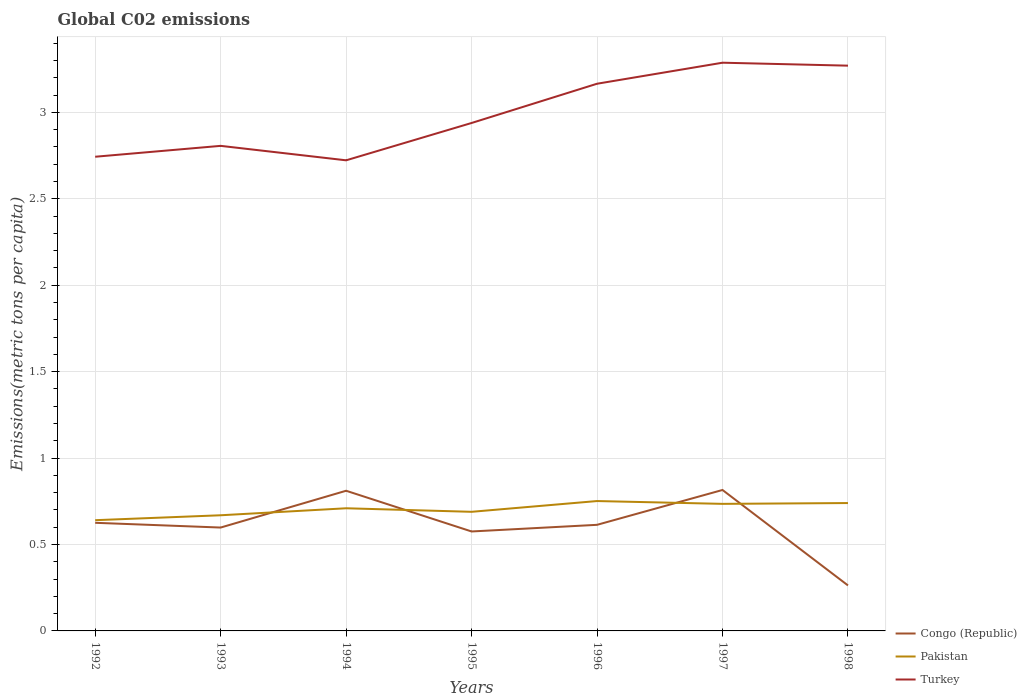Across all years, what is the maximum amount of CO2 emitted in in Pakistan?
Provide a short and direct response. 0.64. In which year was the amount of CO2 emitted in in Pakistan maximum?
Make the answer very short. 1992. What is the total amount of CO2 emitted in in Congo (Republic) in the graph?
Provide a succinct answer. 0.33. What is the difference between the highest and the second highest amount of CO2 emitted in in Turkey?
Keep it short and to the point. 0.56. What is the difference between the highest and the lowest amount of CO2 emitted in in Turkey?
Your response must be concise. 3. How many years are there in the graph?
Provide a succinct answer. 7. Are the values on the major ticks of Y-axis written in scientific E-notation?
Your answer should be very brief. No. How many legend labels are there?
Your answer should be compact. 3. What is the title of the graph?
Keep it short and to the point. Global C02 emissions. What is the label or title of the X-axis?
Ensure brevity in your answer.  Years. What is the label or title of the Y-axis?
Keep it short and to the point. Emissions(metric tons per capita). What is the Emissions(metric tons per capita) in Congo (Republic) in 1992?
Give a very brief answer. 0.63. What is the Emissions(metric tons per capita) in Pakistan in 1992?
Give a very brief answer. 0.64. What is the Emissions(metric tons per capita) of Turkey in 1992?
Provide a short and direct response. 2.74. What is the Emissions(metric tons per capita) in Congo (Republic) in 1993?
Offer a terse response. 0.6. What is the Emissions(metric tons per capita) of Pakistan in 1993?
Provide a short and direct response. 0.67. What is the Emissions(metric tons per capita) in Turkey in 1993?
Provide a short and direct response. 2.81. What is the Emissions(metric tons per capita) of Congo (Republic) in 1994?
Keep it short and to the point. 0.81. What is the Emissions(metric tons per capita) of Pakistan in 1994?
Keep it short and to the point. 0.71. What is the Emissions(metric tons per capita) of Turkey in 1994?
Give a very brief answer. 2.72. What is the Emissions(metric tons per capita) in Congo (Republic) in 1995?
Your response must be concise. 0.58. What is the Emissions(metric tons per capita) of Pakistan in 1995?
Give a very brief answer. 0.69. What is the Emissions(metric tons per capita) of Turkey in 1995?
Provide a short and direct response. 2.94. What is the Emissions(metric tons per capita) in Congo (Republic) in 1996?
Your answer should be very brief. 0.61. What is the Emissions(metric tons per capita) in Pakistan in 1996?
Make the answer very short. 0.75. What is the Emissions(metric tons per capita) in Turkey in 1996?
Ensure brevity in your answer.  3.17. What is the Emissions(metric tons per capita) in Congo (Republic) in 1997?
Keep it short and to the point. 0.82. What is the Emissions(metric tons per capita) of Pakistan in 1997?
Your response must be concise. 0.74. What is the Emissions(metric tons per capita) in Turkey in 1997?
Your answer should be very brief. 3.29. What is the Emissions(metric tons per capita) in Congo (Republic) in 1998?
Ensure brevity in your answer.  0.26. What is the Emissions(metric tons per capita) in Pakistan in 1998?
Keep it short and to the point. 0.74. What is the Emissions(metric tons per capita) in Turkey in 1998?
Provide a succinct answer. 3.27. Across all years, what is the maximum Emissions(metric tons per capita) in Congo (Republic)?
Make the answer very short. 0.82. Across all years, what is the maximum Emissions(metric tons per capita) of Pakistan?
Your response must be concise. 0.75. Across all years, what is the maximum Emissions(metric tons per capita) of Turkey?
Offer a very short reply. 3.29. Across all years, what is the minimum Emissions(metric tons per capita) of Congo (Republic)?
Your response must be concise. 0.26. Across all years, what is the minimum Emissions(metric tons per capita) in Pakistan?
Make the answer very short. 0.64. Across all years, what is the minimum Emissions(metric tons per capita) of Turkey?
Keep it short and to the point. 2.72. What is the total Emissions(metric tons per capita) in Congo (Republic) in the graph?
Your answer should be compact. 4.3. What is the total Emissions(metric tons per capita) of Pakistan in the graph?
Offer a terse response. 4.93. What is the total Emissions(metric tons per capita) of Turkey in the graph?
Make the answer very short. 20.93. What is the difference between the Emissions(metric tons per capita) of Congo (Republic) in 1992 and that in 1993?
Ensure brevity in your answer.  0.03. What is the difference between the Emissions(metric tons per capita) of Pakistan in 1992 and that in 1993?
Ensure brevity in your answer.  -0.03. What is the difference between the Emissions(metric tons per capita) of Turkey in 1992 and that in 1993?
Provide a succinct answer. -0.06. What is the difference between the Emissions(metric tons per capita) of Congo (Republic) in 1992 and that in 1994?
Give a very brief answer. -0.19. What is the difference between the Emissions(metric tons per capita) of Pakistan in 1992 and that in 1994?
Your answer should be compact. -0.07. What is the difference between the Emissions(metric tons per capita) of Turkey in 1992 and that in 1994?
Your response must be concise. 0.02. What is the difference between the Emissions(metric tons per capita) in Congo (Republic) in 1992 and that in 1995?
Your response must be concise. 0.05. What is the difference between the Emissions(metric tons per capita) in Pakistan in 1992 and that in 1995?
Your response must be concise. -0.05. What is the difference between the Emissions(metric tons per capita) in Turkey in 1992 and that in 1995?
Your response must be concise. -0.2. What is the difference between the Emissions(metric tons per capita) of Congo (Republic) in 1992 and that in 1996?
Give a very brief answer. 0.01. What is the difference between the Emissions(metric tons per capita) in Pakistan in 1992 and that in 1996?
Your answer should be very brief. -0.11. What is the difference between the Emissions(metric tons per capita) in Turkey in 1992 and that in 1996?
Ensure brevity in your answer.  -0.42. What is the difference between the Emissions(metric tons per capita) in Congo (Republic) in 1992 and that in 1997?
Offer a terse response. -0.19. What is the difference between the Emissions(metric tons per capita) of Pakistan in 1992 and that in 1997?
Your answer should be compact. -0.09. What is the difference between the Emissions(metric tons per capita) of Turkey in 1992 and that in 1997?
Your response must be concise. -0.54. What is the difference between the Emissions(metric tons per capita) in Congo (Republic) in 1992 and that in 1998?
Offer a terse response. 0.36. What is the difference between the Emissions(metric tons per capita) in Pakistan in 1992 and that in 1998?
Provide a succinct answer. -0.1. What is the difference between the Emissions(metric tons per capita) of Turkey in 1992 and that in 1998?
Offer a terse response. -0.53. What is the difference between the Emissions(metric tons per capita) of Congo (Republic) in 1993 and that in 1994?
Give a very brief answer. -0.21. What is the difference between the Emissions(metric tons per capita) in Pakistan in 1993 and that in 1994?
Your answer should be very brief. -0.04. What is the difference between the Emissions(metric tons per capita) in Turkey in 1993 and that in 1994?
Keep it short and to the point. 0.08. What is the difference between the Emissions(metric tons per capita) in Congo (Republic) in 1993 and that in 1995?
Your response must be concise. 0.02. What is the difference between the Emissions(metric tons per capita) in Pakistan in 1993 and that in 1995?
Your answer should be very brief. -0.02. What is the difference between the Emissions(metric tons per capita) in Turkey in 1993 and that in 1995?
Offer a terse response. -0.13. What is the difference between the Emissions(metric tons per capita) in Congo (Republic) in 1993 and that in 1996?
Give a very brief answer. -0.02. What is the difference between the Emissions(metric tons per capita) of Pakistan in 1993 and that in 1996?
Give a very brief answer. -0.08. What is the difference between the Emissions(metric tons per capita) of Turkey in 1993 and that in 1996?
Keep it short and to the point. -0.36. What is the difference between the Emissions(metric tons per capita) in Congo (Republic) in 1993 and that in 1997?
Offer a terse response. -0.22. What is the difference between the Emissions(metric tons per capita) of Pakistan in 1993 and that in 1997?
Offer a terse response. -0.07. What is the difference between the Emissions(metric tons per capita) in Turkey in 1993 and that in 1997?
Give a very brief answer. -0.48. What is the difference between the Emissions(metric tons per capita) in Congo (Republic) in 1993 and that in 1998?
Keep it short and to the point. 0.33. What is the difference between the Emissions(metric tons per capita) in Pakistan in 1993 and that in 1998?
Your response must be concise. -0.07. What is the difference between the Emissions(metric tons per capita) in Turkey in 1993 and that in 1998?
Keep it short and to the point. -0.46. What is the difference between the Emissions(metric tons per capita) in Congo (Republic) in 1994 and that in 1995?
Offer a terse response. 0.24. What is the difference between the Emissions(metric tons per capita) of Pakistan in 1994 and that in 1995?
Give a very brief answer. 0.02. What is the difference between the Emissions(metric tons per capita) in Turkey in 1994 and that in 1995?
Give a very brief answer. -0.22. What is the difference between the Emissions(metric tons per capita) in Congo (Republic) in 1994 and that in 1996?
Your answer should be compact. 0.2. What is the difference between the Emissions(metric tons per capita) of Pakistan in 1994 and that in 1996?
Your answer should be very brief. -0.04. What is the difference between the Emissions(metric tons per capita) in Turkey in 1994 and that in 1996?
Your response must be concise. -0.44. What is the difference between the Emissions(metric tons per capita) of Congo (Republic) in 1994 and that in 1997?
Provide a succinct answer. -0. What is the difference between the Emissions(metric tons per capita) in Pakistan in 1994 and that in 1997?
Ensure brevity in your answer.  -0.03. What is the difference between the Emissions(metric tons per capita) in Turkey in 1994 and that in 1997?
Provide a short and direct response. -0.56. What is the difference between the Emissions(metric tons per capita) of Congo (Republic) in 1994 and that in 1998?
Your response must be concise. 0.55. What is the difference between the Emissions(metric tons per capita) of Pakistan in 1994 and that in 1998?
Provide a succinct answer. -0.03. What is the difference between the Emissions(metric tons per capita) of Turkey in 1994 and that in 1998?
Your answer should be very brief. -0.55. What is the difference between the Emissions(metric tons per capita) of Congo (Republic) in 1995 and that in 1996?
Ensure brevity in your answer.  -0.04. What is the difference between the Emissions(metric tons per capita) of Pakistan in 1995 and that in 1996?
Ensure brevity in your answer.  -0.06. What is the difference between the Emissions(metric tons per capita) in Turkey in 1995 and that in 1996?
Make the answer very short. -0.23. What is the difference between the Emissions(metric tons per capita) in Congo (Republic) in 1995 and that in 1997?
Your answer should be very brief. -0.24. What is the difference between the Emissions(metric tons per capita) in Pakistan in 1995 and that in 1997?
Offer a very short reply. -0.05. What is the difference between the Emissions(metric tons per capita) in Turkey in 1995 and that in 1997?
Your answer should be very brief. -0.35. What is the difference between the Emissions(metric tons per capita) of Congo (Republic) in 1995 and that in 1998?
Offer a very short reply. 0.31. What is the difference between the Emissions(metric tons per capita) of Pakistan in 1995 and that in 1998?
Make the answer very short. -0.05. What is the difference between the Emissions(metric tons per capita) of Turkey in 1995 and that in 1998?
Your answer should be very brief. -0.33. What is the difference between the Emissions(metric tons per capita) in Congo (Republic) in 1996 and that in 1997?
Make the answer very short. -0.2. What is the difference between the Emissions(metric tons per capita) in Pakistan in 1996 and that in 1997?
Your answer should be very brief. 0.02. What is the difference between the Emissions(metric tons per capita) in Turkey in 1996 and that in 1997?
Ensure brevity in your answer.  -0.12. What is the difference between the Emissions(metric tons per capita) of Congo (Republic) in 1996 and that in 1998?
Offer a terse response. 0.35. What is the difference between the Emissions(metric tons per capita) of Pakistan in 1996 and that in 1998?
Keep it short and to the point. 0.01. What is the difference between the Emissions(metric tons per capita) in Turkey in 1996 and that in 1998?
Provide a succinct answer. -0.1. What is the difference between the Emissions(metric tons per capita) in Congo (Republic) in 1997 and that in 1998?
Ensure brevity in your answer.  0.55. What is the difference between the Emissions(metric tons per capita) of Pakistan in 1997 and that in 1998?
Offer a very short reply. -0. What is the difference between the Emissions(metric tons per capita) in Turkey in 1997 and that in 1998?
Your answer should be very brief. 0.02. What is the difference between the Emissions(metric tons per capita) in Congo (Republic) in 1992 and the Emissions(metric tons per capita) in Pakistan in 1993?
Provide a short and direct response. -0.04. What is the difference between the Emissions(metric tons per capita) in Congo (Republic) in 1992 and the Emissions(metric tons per capita) in Turkey in 1993?
Your answer should be compact. -2.18. What is the difference between the Emissions(metric tons per capita) of Pakistan in 1992 and the Emissions(metric tons per capita) of Turkey in 1993?
Your answer should be very brief. -2.17. What is the difference between the Emissions(metric tons per capita) in Congo (Republic) in 1992 and the Emissions(metric tons per capita) in Pakistan in 1994?
Ensure brevity in your answer.  -0.08. What is the difference between the Emissions(metric tons per capita) of Congo (Republic) in 1992 and the Emissions(metric tons per capita) of Turkey in 1994?
Provide a succinct answer. -2.1. What is the difference between the Emissions(metric tons per capita) of Pakistan in 1992 and the Emissions(metric tons per capita) of Turkey in 1994?
Keep it short and to the point. -2.08. What is the difference between the Emissions(metric tons per capita) of Congo (Republic) in 1992 and the Emissions(metric tons per capita) of Pakistan in 1995?
Keep it short and to the point. -0.06. What is the difference between the Emissions(metric tons per capita) in Congo (Republic) in 1992 and the Emissions(metric tons per capita) in Turkey in 1995?
Your response must be concise. -2.31. What is the difference between the Emissions(metric tons per capita) in Pakistan in 1992 and the Emissions(metric tons per capita) in Turkey in 1995?
Your answer should be very brief. -2.3. What is the difference between the Emissions(metric tons per capita) of Congo (Republic) in 1992 and the Emissions(metric tons per capita) of Pakistan in 1996?
Give a very brief answer. -0.13. What is the difference between the Emissions(metric tons per capita) of Congo (Republic) in 1992 and the Emissions(metric tons per capita) of Turkey in 1996?
Make the answer very short. -2.54. What is the difference between the Emissions(metric tons per capita) in Pakistan in 1992 and the Emissions(metric tons per capita) in Turkey in 1996?
Keep it short and to the point. -2.52. What is the difference between the Emissions(metric tons per capita) in Congo (Republic) in 1992 and the Emissions(metric tons per capita) in Pakistan in 1997?
Provide a short and direct response. -0.11. What is the difference between the Emissions(metric tons per capita) in Congo (Republic) in 1992 and the Emissions(metric tons per capita) in Turkey in 1997?
Provide a short and direct response. -2.66. What is the difference between the Emissions(metric tons per capita) in Pakistan in 1992 and the Emissions(metric tons per capita) in Turkey in 1997?
Provide a short and direct response. -2.65. What is the difference between the Emissions(metric tons per capita) in Congo (Republic) in 1992 and the Emissions(metric tons per capita) in Pakistan in 1998?
Your answer should be very brief. -0.11. What is the difference between the Emissions(metric tons per capita) in Congo (Republic) in 1992 and the Emissions(metric tons per capita) in Turkey in 1998?
Keep it short and to the point. -2.64. What is the difference between the Emissions(metric tons per capita) of Pakistan in 1992 and the Emissions(metric tons per capita) of Turkey in 1998?
Your answer should be compact. -2.63. What is the difference between the Emissions(metric tons per capita) in Congo (Republic) in 1993 and the Emissions(metric tons per capita) in Pakistan in 1994?
Provide a succinct answer. -0.11. What is the difference between the Emissions(metric tons per capita) of Congo (Republic) in 1993 and the Emissions(metric tons per capita) of Turkey in 1994?
Keep it short and to the point. -2.12. What is the difference between the Emissions(metric tons per capita) of Pakistan in 1993 and the Emissions(metric tons per capita) of Turkey in 1994?
Your answer should be very brief. -2.05. What is the difference between the Emissions(metric tons per capita) in Congo (Republic) in 1993 and the Emissions(metric tons per capita) in Pakistan in 1995?
Your response must be concise. -0.09. What is the difference between the Emissions(metric tons per capita) of Congo (Republic) in 1993 and the Emissions(metric tons per capita) of Turkey in 1995?
Ensure brevity in your answer.  -2.34. What is the difference between the Emissions(metric tons per capita) in Pakistan in 1993 and the Emissions(metric tons per capita) in Turkey in 1995?
Your response must be concise. -2.27. What is the difference between the Emissions(metric tons per capita) of Congo (Republic) in 1993 and the Emissions(metric tons per capita) of Pakistan in 1996?
Offer a terse response. -0.15. What is the difference between the Emissions(metric tons per capita) in Congo (Republic) in 1993 and the Emissions(metric tons per capita) in Turkey in 1996?
Your answer should be very brief. -2.57. What is the difference between the Emissions(metric tons per capita) of Pakistan in 1993 and the Emissions(metric tons per capita) of Turkey in 1996?
Give a very brief answer. -2.5. What is the difference between the Emissions(metric tons per capita) of Congo (Republic) in 1993 and the Emissions(metric tons per capita) of Pakistan in 1997?
Provide a short and direct response. -0.14. What is the difference between the Emissions(metric tons per capita) of Congo (Republic) in 1993 and the Emissions(metric tons per capita) of Turkey in 1997?
Your answer should be compact. -2.69. What is the difference between the Emissions(metric tons per capita) of Pakistan in 1993 and the Emissions(metric tons per capita) of Turkey in 1997?
Your response must be concise. -2.62. What is the difference between the Emissions(metric tons per capita) in Congo (Republic) in 1993 and the Emissions(metric tons per capita) in Pakistan in 1998?
Offer a very short reply. -0.14. What is the difference between the Emissions(metric tons per capita) in Congo (Republic) in 1993 and the Emissions(metric tons per capita) in Turkey in 1998?
Give a very brief answer. -2.67. What is the difference between the Emissions(metric tons per capita) in Pakistan in 1993 and the Emissions(metric tons per capita) in Turkey in 1998?
Make the answer very short. -2.6. What is the difference between the Emissions(metric tons per capita) in Congo (Republic) in 1994 and the Emissions(metric tons per capita) in Pakistan in 1995?
Keep it short and to the point. 0.12. What is the difference between the Emissions(metric tons per capita) of Congo (Republic) in 1994 and the Emissions(metric tons per capita) of Turkey in 1995?
Ensure brevity in your answer.  -2.13. What is the difference between the Emissions(metric tons per capita) in Pakistan in 1994 and the Emissions(metric tons per capita) in Turkey in 1995?
Offer a terse response. -2.23. What is the difference between the Emissions(metric tons per capita) in Congo (Republic) in 1994 and the Emissions(metric tons per capita) in Pakistan in 1996?
Offer a very short reply. 0.06. What is the difference between the Emissions(metric tons per capita) of Congo (Republic) in 1994 and the Emissions(metric tons per capita) of Turkey in 1996?
Ensure brevity in your answer.  -2.35. What is the difference between the Emissions(metric tons per capita) in Pakistan in 1994 and the Emissions(metric tons per capita) in Turkey in 1996?
Give a very brief answer. -2.46. What is the difference between the Emissions(metric tons per capita) of Congo (Republic) in 1994 and the Emissions(metric tons per capita) of Pakistan in 1997?
Provide a succinct answer. 0.08. What is the difference between the Emissions(metric tons per capita) of Congo (Republic) in 1994 and the Emissions(metric tons per capita) of Turkey in 1997?
Offer a terse response. -2.48. What is the difference between the Emissions(metric tons per capita) of Pakistan in 1994 and the Emissions(metric tons per capita) of Turkey in 1997?
Your answer should be very brief. -2.58. What is the difference between the Emissions(metric tons per capita) of Congo (Republic) in 1994 and the Emissions(metric tons per capita) of Pakistan in 1998?
Give a very brief answer. 0.07. What is the difference between the Emissions(metric tons per capita) of Congo (Republic) in 1994 and the Emissions(metric tons per capita) of Turkey in 1998?
Keep it short and to the point. -2.46. What is the difference between the Emissions(metric tons per capita) of Pakistan in 1994 and the Emissions(metric tons per capita) of Turkey in 1998?
Provide a succinct answer. -2.56. What is the difference between the Emissions(metric tons per capita) of Congo (Republic) in 1995 and the Emissions(metric tons per capita) of Pakistan in 1996?
Provide a succinct answer. -0.18. What is the difference between the Emissions(metric tons per capita) of Congo (Republic) in 1995 and the Emissions(metric tons per capita) of Turkey in 1996?
Offer a terse response. -2.59. What is the difference between the Emissions(metric tons per capita) in Pakistan in 1995 and the Emissions(metric tons per capita) in Turkey in 1996?
Make the answer very short. -2.48. What is the difference between the Emissions(metric tons per capita) in Congo (Republic) in 1995 and the Emissions(metric tons per capita) in Pakistan in 1997?
Give a very brief answer. -0.16. What is the difference between the Emissions(metric tons per capita) in Congo (Republic) in 1995 and the Emissions(metric tons per capita) in Turkey in 1997?
Your answer should be compact. -2.71. What is the difference between the Emissions(metric tons per capita) of Pakistan in 1995 and the Emissions(metric tons per capita) of Turkey in 1997?
Give a very brief answer. -2.6. What is the difference between the Emissions(metric tons per capita) in Congo (Republic) in 1995 and the Emissions(metric tons per capita) in Pakistan in 1998?
Provide a succinct answer. -0.16. What is the difference between the Emissions(metric tons per capita) of Congo (Republic) in 1995 and the Emissions(metric tons per capita) of Turkey in 1998?
Provide a short and direct response. -2.69. What is the difference between the Emissions(metric tons per capita) of Pakistan in 1995 and the Emissions(metric tons per capita) of Turkey in 1998?
Give a very brief answer. -2.58. What is the difference between the Emissions(metric tons per capita) of Congo (Republic) in 1996 and the Emissions(metric tons per capita) of Pakistan in 1997?
Give a very brief answer. -0.12. What is the difference between the Emissions(metric tons per capita) in Congo (Republic) in 1996 and the Emissions(metric tons per capita) in Turkey in 1997?
Give a very brief answer. -2.67. What is the difference between the Emissions(metric tons per capita) in Pakistan in 1996 and the Emissions(metric tons per capita) in Turkey in 1997?
Your answer should be compact. -2.54. What is the difference between the Emissions(metric tons per capita) in Congo (Republic) in 1996 and the Emissions(metric tons per capita) in Pakistan in 1998?
Offer a terse response. -0.13. What is the difference between the Emissions(metric tons per capita) of Congo (Republic) in 1996 and the Emissions(metric tons per capita) of Turkey in 1998?
Your answer should be very brief. -2.66. What is the difference between the Emissions(metric tons per capita) in Pakistan in 1996 and the Emissions(metric tons per capita) in Turkey in 1998?
Your answer should be very brief. -2.52. What is the difference between the Emissions(metric tons per capita) of Congo (Republic) in 1997 and the Emissions(metric tons per capita) of Pakistan in 1998?
Make the answer very short. 0.08. What is the difference between the Emissions(metric tons per capita) of Congo (Republic) in 1997 and the Emissions(metric tons per capita) of Turkey in 1998?
Provide a short and direct response. -2.45. What is the difference between the Emissions(metric tons per capita) in Pakistan in 1997 and the Emissions(metric tons per capita) in Turkey in 1998?
Offer a terse response. -2.54. What is the average Emissions(metric tons per capita) of Congo (Republic) per year?
Make the answer very short. 0.61. What is the average Emissions(metric tons per capita) of Pakistan per year?
Offer a very short reply. 0.7. What is the average Emissions(metric tons per capita) in Turkey per year?
Keep it short and to the point. 2.99. In the year 1992, what is the difference between the Emissions(metric tons per capita) in Congo (Republic) and Emissions(metric tons per capita) in Pakistan?
Your answer should be compact. -0.02. In the year 1992, what is the difference between the Emissions(metric tons per capita) of Congo (Republic) and Emissions(metric tons per capita) of Turkey?
Give a very brief answer. -2.12. In the year 1992, what is the difference between the Emissions(metric tons per capita) of Pakistan and Emissions(metric tons per capita) of Turkey?
Provide a succinct answer. -2.1. In the year 1993, what is the difference between the Emissions(metric tons per capita) of Congo (Republic) and Emissions(metric tons per capita) of Pakistan?
Offer a terse response. -0.07. In the year 1993, what is the difference between the Emissions(metric tons per capita) in Congo (Republic) and Emissions(metric tons per capita) in Turkey?
Give a very brief answer. -2.21. In the year 1993, what is the difference between the Emissions(metric tons per capita) of Pakistan and Emissions(metric tons per capita) of Turkey?
Keep it short and to the point. -2.14. In the year 1994, what is the difference between the Emissions(metric tons per capita) in Congo (Republic) and Emissions(metric tons per capita) in Pakistan?
Provide a succinct answer. 0.1. In the year 1994, what is the difference between the Emissions(metric tons per capita) of Congo (Republic) and Emissions(metric tons per capita) of Turkey?
Your answer should be very brief. -1.91. In the year 1994, what is the difference between the Emissions(metric tons per capita) in Pakistan and Emissions(metric tons per capita) in Turkey?
Give a very brief answer. -2.01. In the year 1995, what is the difference between the Emissions(metric tons per capita) in Congo (Republic) and Emissions(metric tons per capita) in Pakistan?
Ensure brevity in your answer.  -0.11. In the year 1995, what is the difference between the Emissions(metric tons per capita) of Congo (Republic) and Emissions(metric tons per capita) of Turkey?
Offer a very short reply. -2.36. In the year 1995, what is the difference between the Emissions(metric tons per capita) of Pakistan and Emissions(metric tons per capita) of Turkey?
Your answer should be compact. -2.25. In the year 1996, what is the difference between the Emissions(metric tons per capita) of Congo (Republic) and Emissions(metric tons per capita) of Pakistan?
Provide a short and direct response. -0.14. In the year 1996, what is the difference between the Emissions(metric tons per capita) of Congo (Republic) and Emissions(metric tons per capita) of Turkey?
Provide a short and direct response. -2.55. In the year 1996, what is the difference between the Emissions(metric tons per capita) in Pakistan and Emissions(metric tons per capita) in Turkey?
Your response must be concise. -2.41. In the year 1997, what is the difference between the Emissions(metric tons per capita) of Congo (Republic) and Emissions(metric tons per capita) of Pakistan?
Make the answer very short. 0.08. In the year 1997, what is the difference between the Emissions(metric tons per capita) of Congo (Republic) and Emissions(metric tons per capita) of Turkey?
Give a very brief answer. -2.47. In the year 1997, what is the difference between the Emissions(metric tons per capita) of Pakistan and Emissions(metric tons per capita) of Turkey?
Ensure brevity in your answer.  -2.55. In the year 1998, what is the difference between the Emissions(metric tons per capita) in Congo (Republic) and Emissions(metric tons per capita) in Pakistan?
Offer a terse response. -0.48. In the year 1998, what is the difference between the Emissions(metric tons per capita) of Congo (Republic) and Emissions(metric tons per capita) of Turkey?
Give a very brief answer. -3.01. In the year 1998, what is the difference between the Emissions(metric tons per capita) in Pakistan and Emissions(metric tons per capita) in Turkey?
Give a very brief answer. -2.53. What is the ratio of the Emissions(metric tons per capita) in Congo (Republic) in 1992 to that in 1993?
Give a very brief answer. 1.05. What is the ratio of the Emissions(metric tons per capita) of Pakistan in 1992 to that in 1993?
Offer a very short reply. 0.96. What is the ratio of the Emissions(metric tons per capita) in Turkey in 1992 to that in 1993?
Your answer should be very brief. 0.98. What is the ratio of the Emissions(metric tons per capita) of Congo (Republic) in 1992 to that in 1994?
Your answer should be compact. 0.77. What is the ratio of the Emissions(metric tons per capita) in Pakistan in 1992 to that in 1994?
Your response must be concise. 0.9. What is the ratio of the Emissions(metric tons per capita) in Turkey in 1992 to that in 1994?
Provide a succinct answer. 1.01. What is the ratio of the Emissions(metric tons per capita) in Congo (Republic) in 1992 to that in 1995?
Your answer should be very brief. 1.09. What is the ratio of the Emissions(metric tons per capita) in Pakistan in 1992 to that in 1995?
Your answer should be very brief. 0.93. What is the ratio of the Emissions(metric tons per capita) in Turkey in 1992 to that in 1995?
Give a very brief answer. 0.93. What is the ratio of the Emissions(metric tons per capita) of Congo (Republic) in 1992 to that in 1996?
Give a very brief answer. 1.02. What is the ratio of the Emissions(metric tons per capita) in Pakistan in 1992 to that in 1996?
Ensure brevity in your answer.  0.85. What is the ratio of the Emissions(metric tons per capita) in Turkey in 1992 to that in 1996?
Ensure brevity in your answer.  0.87. What is the ratio of the Emissions(metric tons per capita) of Congo (Republic) in 1992 to that in 1997?
Your answer should be very brief. 0.77. What is the ratio of the Emissions(metric tons per capita) in Pakistan in 1992 to that in 1997?
Offer a terse response. 0.87. What is the ratio of the Emissions(metric tons per capita) of Turkey in 1992 to that in 1997?
Provide a succinct answer. 0.83. What is the ratio of the Emissions(metric tons per capita) in Congo (Republic) in 1992 to that in 1998?
Your answer should be very brief. 2.38. What is the ratio of the Emissions(metric tons per capita) in Pakistan in 1992 to that in 1998?
Your answer should be very brief. 0.87. What is the ratio of the Emissions(metric tons per capita) of Turkey in 1992 to that in 1998?
Your answer should be compact. 0.84. What is the ratio of the Emissions(metric tons per capita) of Congo (Republic) in 1993 to that in 1994?
Offer a very short reply. 0.74. What is the ratio of the Emissions(metric tons per capita) of Pakistan in 1993 to that in 1994?
Offer a terse response. 0.94. What is the ratio of the Emissions(metric tons per capita) in Turkey in 1993 to that in 1994?
Ensure brevity in your answer.  1.03. What is the ratio of the Emissions(metric tons per capita) of Congo (Republic) in 1993 to that in 1995?
Give a very brief answer. 1.04. What is the ratio of the Emissions(metric tons per capita) in Turkey in 1993 to that in 1995?
Your answer should be compact. 0.95. What is the ratio of the Emissions(metric tons per capita) of Congo (Republic) in 1993 to that in 1996?
Provide a short and direct response. 0.97. What is the ratio of the Emissions(metric tons per capita) of Pakistan in 1993 to that in 1996?
Give a very brief answer. 0.89. What is the ratio of the Emissions(metric tons per capita) of Turkey in 1993 to that in 1996?
Your answer should be very brief. 0.89. What is the ratio of the Emissions(metric tons per capita) in Congo (Republic) in 1993 to that in 1997?
Make the answer very short. 0.73. What is the ratio of the Emissions(metric tons per capita) of Pakistan in 1993 to that in 1997?
Provide a succinct answer. 0.91. What is the ratio of the Emissions(metric tons per capita) of Turkey in 1993 to that in 1997?
Your answer should be very brief. 0.85. What is the ratio of the Emissions(metric tons per capita) in Congo (Republic) in 1993 to that in 1998?
Offer a very short reply. 2.27. What is the ratio of the Emissions(metric tons per capita) of Pakistan in 1993 to that in 1998?
Provide a succinct answer. 0.9. What is the ratio of the Emissions(metric tons per capita) in Turkey in 1993 to that in 1998?
Your answer should be very brief. 0.86. What is the ratio of the Emissions(metric tons per capita) in Congo (Republic) in 1994 to that in 1995?
Offer a very short reply. 1.41. What is the ratio of the Emissions(metric tons per capita) of Pakistan in 1994 to that in 1995?
Your response must be concise. 1.03. What is the ratio of the Emissions(metric tons per capita) of Turkey in 1994 to that in 1995?
Offer a terse response. 0.93. What is the ratio of the Emissions(metric tons per capita) of Congo (Republic) in 1994 to that in 1996?
Your answer should be compact. 1.32. What is the ratio of the Emissions(metric tons per capita) of Pakistan in 1994 to that in 1996?
Offer a very short reply. 0.94. What is the ratio of the Emissions(metric tons per capita) of Turkey in 1994 to that in 1996?
Offer a very short reply. 0.86. What is the ratio of the Emissions(metric tons per capita) of Pakistan in 1994 to that in 1997?
Ensure brevity in your answer.  0.97. What is the ratio of the Emissions(metric tons per capita) of Turkey in 1994 to that in 1997?
Give a very brief answer. 0.83. What is the ratio of the Emissions(metric tons per capita) of Congo (Republic) in 1994 to that in 1998?
Your response must be concise. 3.08. What is the ratio of the Emissions(metric tons per capita) of Pakistan in 1994 to that in 1998?
Offer a terse response. 0.96. What is the ratio of the Emissions(metric tons per capita) of Turkey in 1994 to that in 1998?
Keep it short and to the point. 0.83. What is the ratio of the Emissions(metric tons per capita) of Congo (Republic) in 1995 to that in 1996?
Make the answer very short. 0.94. What is the ratio of the Emissions(metric tons per capita) of Pakistan in 1995 to that in 1996?
Ensure brevity in your answer.  0.92. What is the ratio of the Emissions(metric tons per capita) of Turkey in 1995 to that in 1996?
Make the answer very short. 0.93. What is the ratio of the Emissions(metric tons per capita) of Congo (Republic) in 1995 to that in 1997?
Provide a short and direct response. 0.71. What is the ratio of the Emissions(metric tons per capita) of Pakistan in 1995 to that in 1997?
Offer a terse response. 0.94. What is the ratio of the Emissions(metric tons per capita) in Turkey in 1995 to that in 1997?
Your answer should be very brief. 0.89. What is the ratio of the Emissions(metric tons per capita) of Congo (Republic) in 1995 to that in 1998?
Provide a short and direct response. 2.19. What is the ratio of the Emissions(metric tons per capita) of Pakistan in 1995 to that in 1998?
Offer a very short reply. 0.93. What is the ratio of the Emissions(metric tons per capita) of Turkey in 1995 to that in 1998?
Your response must be concise. 0.9. What is the ratio of the Emissions(metric tons per capita) in Congo (Republic) in 1996 to that in 1997?
Your response must be concise. 0.75. What is the ratio of the Emissions(metric tons per capita) of Pakistan in 1996 to that in 1997?
Your answer should be compact. 1.02. What is the ratio of the Emissions(metric tons per capita) of Congo (Republic) in 1996 to that in 1998?
Offer a very short reply. 2.33. What is the ratio of the Emissions(metric tons per capita) in Pakistan in 1996 to that in 1998?
Offer a very short reply. 1.02. What is the ratio of the Emissions(metric tons per capita) of Turkey in 1996 to that in 1998?
Offer a very short reply. 0.97. What is the ratio of the Emissions(metric tons per capita) of Congo (Republic) in 1997 to that in 1998?
Provide a succinct answer. 3.1. What is the ratio of the Emissions(metric tons per capita) in Pakistan in 1997 to that in 1998?
Provide a succinct answer. 0.99. What is the difference between the highest and the second highest Emissions(metric tons per capita) in Congo (Republic)?
Your response must be concise. 0. What is the difference between the highest and the second highest Emissions(metric tons per capita) in Pakistan?
Provide a short and direct response. 0.01. What is the difference between the highest and the second highest Emissions(metric tons per capita) of Turkey?
Your answer should be compact. 0.02. What is the difference between the highest and the lowest Emissions(metric tons per capita) in Congo (Republic)?
Keep it short and to the point. 0.55. What is the difference between the highest and the lowest Emissions(metric tons per capita) of Pakistan?
Ensure brevity in your answer.  0.11. What is the difference between the highest and the lowest Emissions(metric tons per capita) of Turkey?
Your answer should be compact. 0.56. 